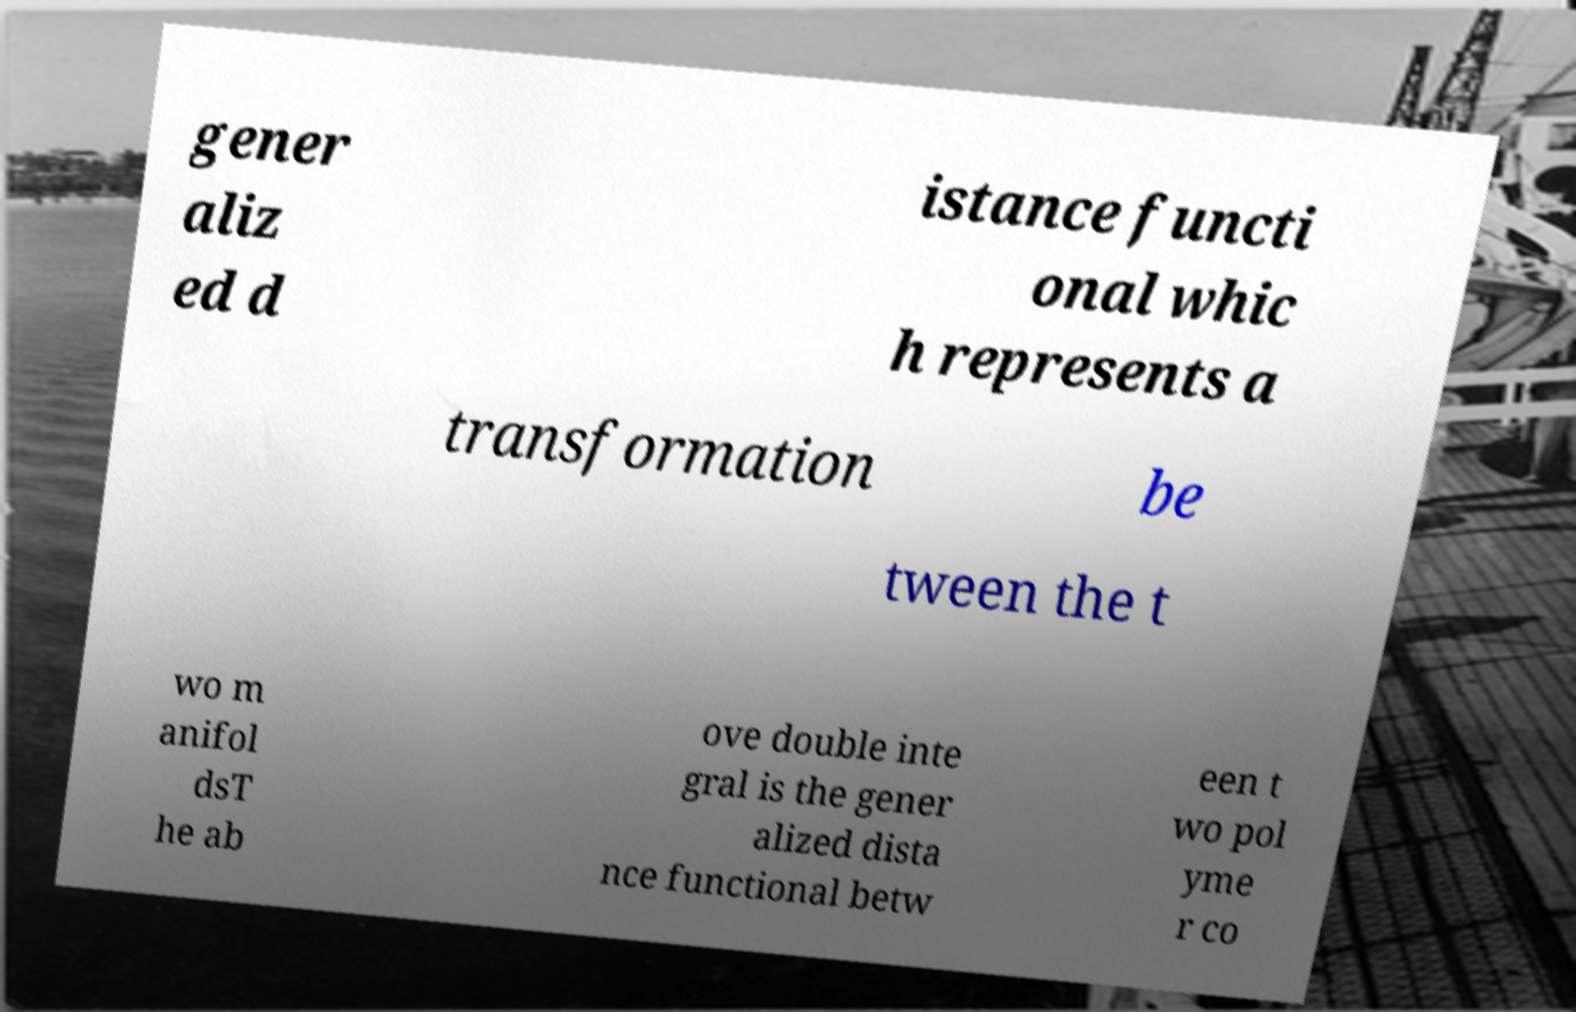Can you read and provide the text displayed in the image?This photo seems to have some interesting text. Can you extract and type it out for me? gener aliz ed d istance functi onal whic h represents a transformation be tween the t wo m anifol dsT he ab ove double inte gral is the gener alized dista nce functional betw een t wo pol yme r co 